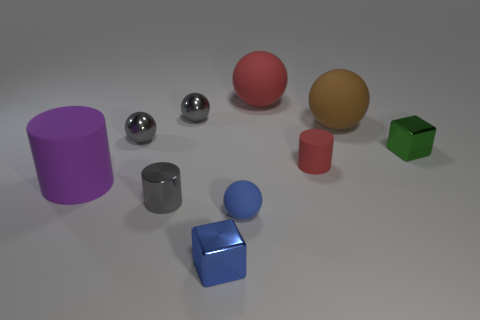Subtract all red spheres. How many spheres are left? 4 Subtract all yellow spheres. Subtract all red cylinders. How many spheres are left? 5 Subtract all cubes. How many objects are left? 8 Add 8 red rubber spheres. How many red rubber spheres are left? 9 Add 4 tiny green things. How many tiny green things exist? 5 Subtract 1 blue cubes. How many objects are left? 9 Subtract all tiny metallic spheres. Subtract all tiny metallic things. How many objects are left? 3 